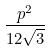Convert formula to latex. <formula><loc_0><loc_0><loc_500><loc_500>\frac { p ^ { 2 } } { 1 2 \sqrt { 3 } }</formula> 